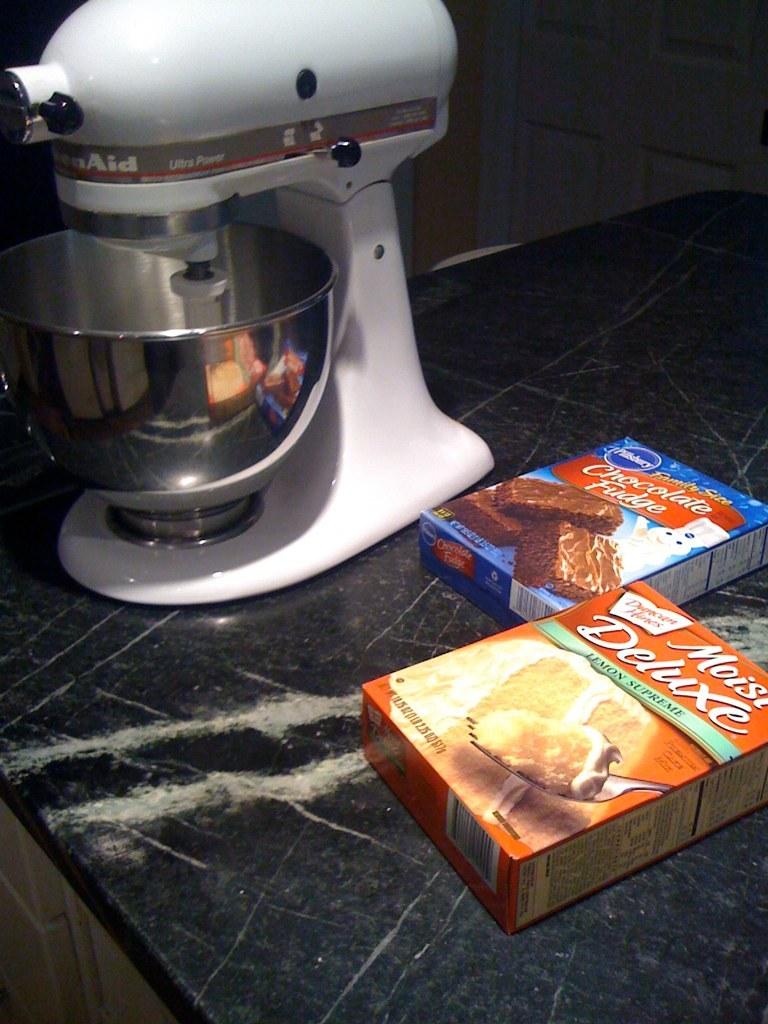How many items are on the table?
Your answer should be compact. Answering does not require reading text in the image. What variation of cake is in the red box?
Your response must be concise. Lemon supreme. 